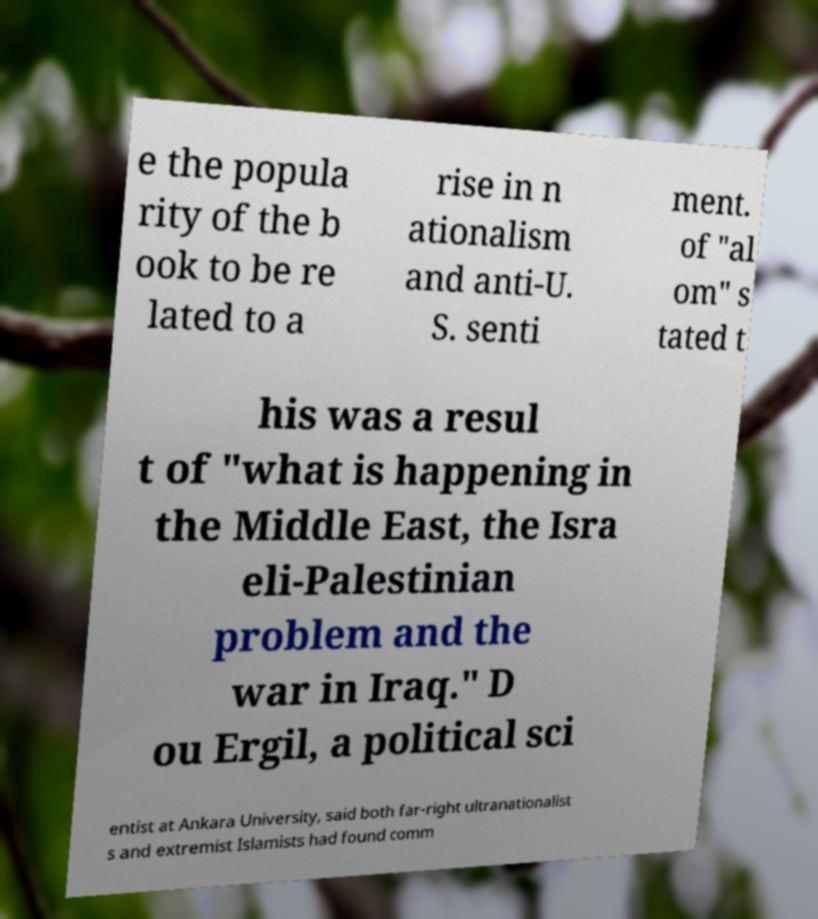Can you accurately transcribe the text from the provided image for me? e the popula rity of the b ook to be re lated to a rise in n ationalism and anti-U. S. senti ment. of "al om" s tated t his was a resul t of "what is happening in the Middle East, the Isra eli-Palestinian problem and the war in Iraq." D ou Ergil, a political sci entist at Ankara University, said both far-right ultranationalist s and extremist Islamists had found comm 